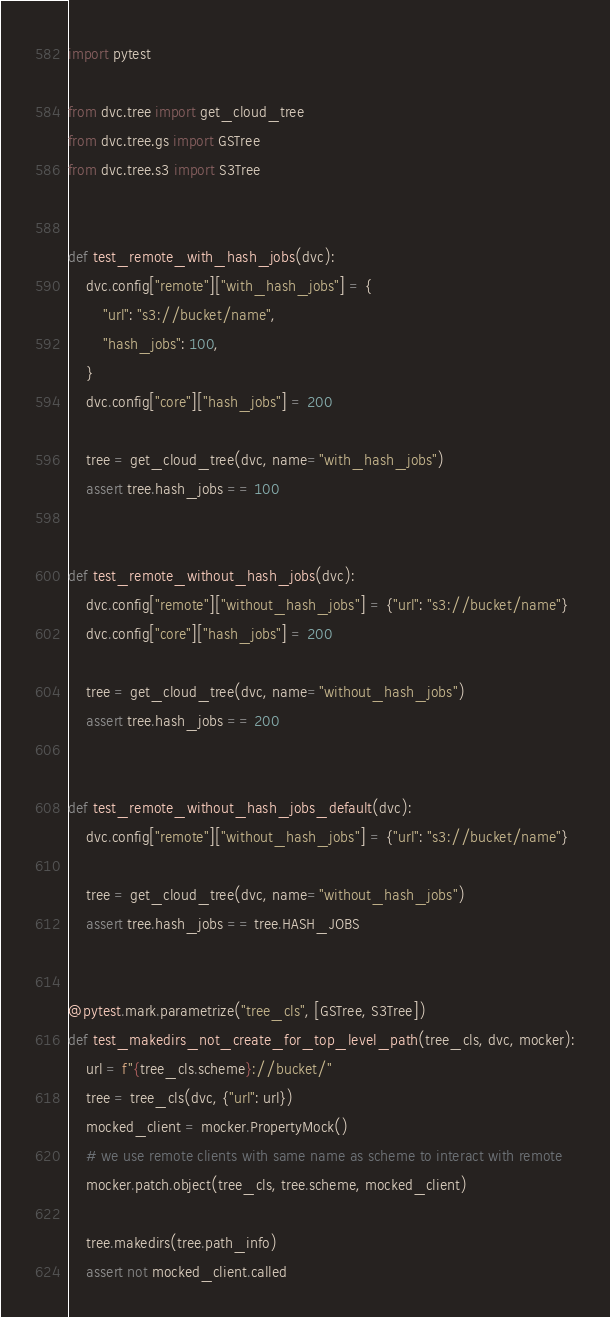<code> <loc_0><loc_0><loc_500><loc_500><_Python_>import pytest

from dvc.tree import get_cloud_tree
from dvc.tree.gs import GSTree
from dvc.tree.s3 import S3Tree


def test_remote_with_hash_jobs(dvc):
    dvc.config["remote"]["with_hash_jobs"] = {
        "url": "s3://bucket/name",
        "hash_jobs": 100,
    }
    dvc.config["core"]["hash_jobs"] = 200

    tree = get_cloud_tree(dvc, name="with_hash_jobs")
    assert tree.hash_jobs == 100


def test_remote_without_hash_jobs(dvc):
    dvc.config["remote"]["without_hash_jobs"] = {"url": "s3://bucket/name"}
    dvc.config["core"]["hash_jobs"] = 200

    tree = get_cloud_tree(dvc, name="without_hash_jobs")
    assert tree.hash_jobs == 200


def test_remote_without_hash_jobs_default(dvc):
    dvc.config["remote"]["without_hash_jobs"] = {"url": "s3://bucket/name"}

    tree = get_cloud_tree(dvc, name="without_hash_jobs")
    assert tree.hash_jobs == tree.HASH_JOBS


@pytest.mark.parametrize("tree_cls", [GSTree, S3Tree])
def test_makedirs_not_create_for_top_level_path(tree_cls, dvc, mocker):
    url = f"{tree_cls.scheme}://bucket/"
    tree = tree_cls(dvc, {"url": url})
    mocked_client = mocker.PropertyMock()
    # we use remote clients with same name as scheme to interact with remote
    mocker.patch.object(tree_cls, tree.scheme, mocked_client)

    tree.makedirs(tree.path_info)
    assert not mocked_client.called
</code> 